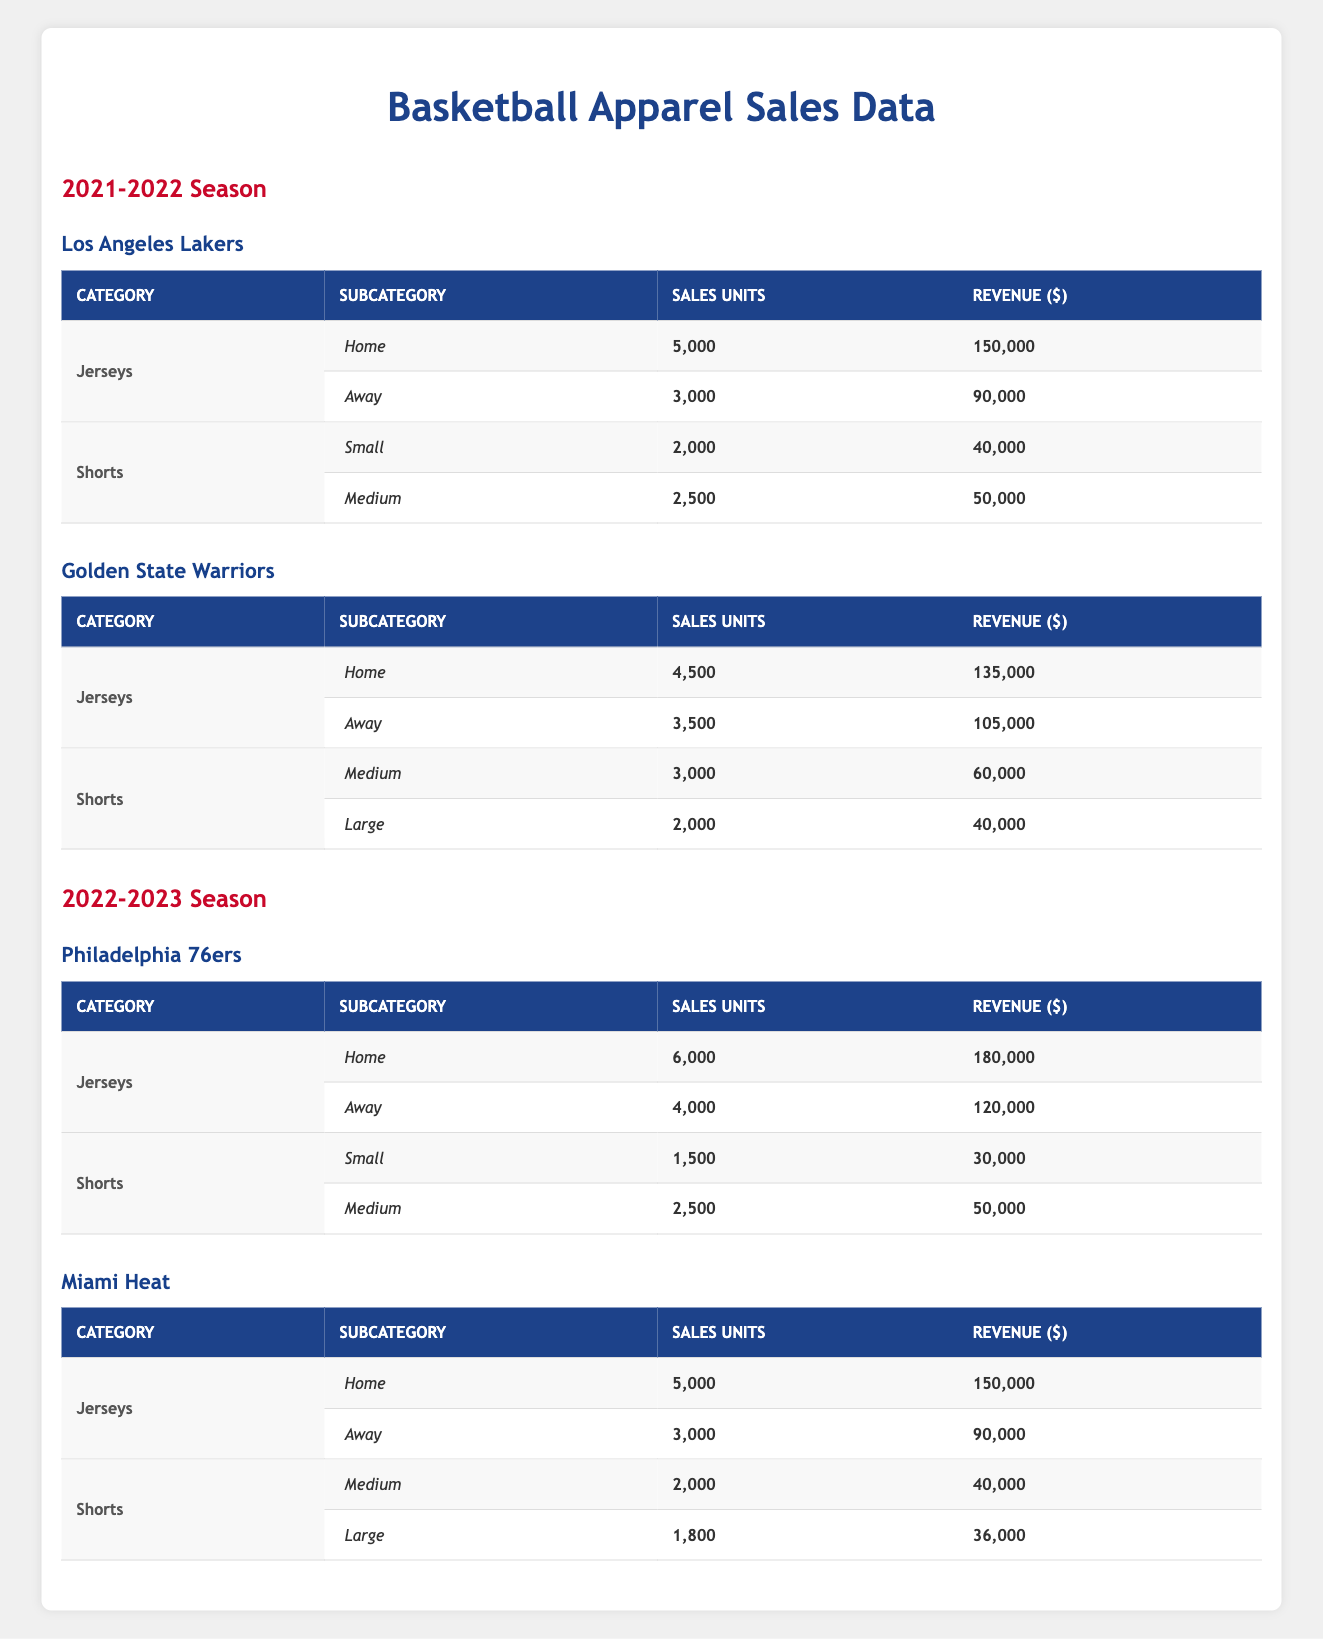What are the total sales units for the Los Angeles Lakers' jerseys in the 2021-2022 season? The total sales units for the Los Angeles Lakers' jerseys can be found by adding the sales units for both home and away jerseys. Home jersey sales are 5,000 units and away jersey sales are 3,000 units. Therefore, 5,000 + 3,000 = 8,000 total sales units.
Answer: 8,000 Which team had the highest revenue from away jerseys in the 2021-2022 season? The away jersey revenue for Golden State Warriors is 105,000, and for Los Angeles Lakers, it is 90,000. Comparing both, 105,000 is greater than 90,000, thus the Golden State Warriors had the highest revenue from away jerseys.
Answer: Golden State Warriors What is the average revenue from shorts for the Miami Heat in the 2022-2023 season? For Miami Heat in the 2022-2023 season, the revenue from medium shorts is 40,000 and from large shorts is 36,000. To find the average, sum the revenues: 40,000 + 36,000 = 76,000, and then divide by 2 (the number of short types), giving 76,000 / 2 = 38,000.
Answer: 38,000 Did the Philadelphia 76ers sell more than 5,000 home jerseys in the 2022-2023 season? The home jersey sales units for Philadelphia 76ers are 6,000. Since 6,000 is greater than 5,000, the answer is yes.
Answer: Yes What was the total revenue from sales of jerseys for the Golden State Warriors in the 2021-2022 season? The total revenue from Golden State Warriors jerseys includes home and away jersey sales. Home jersey revenue is 135,000 and away jersey revenue is 105,000. Adding these gives 135,000 + 105,000 = 240,000 total revenue from jersey sales.
Answer: 240,000 